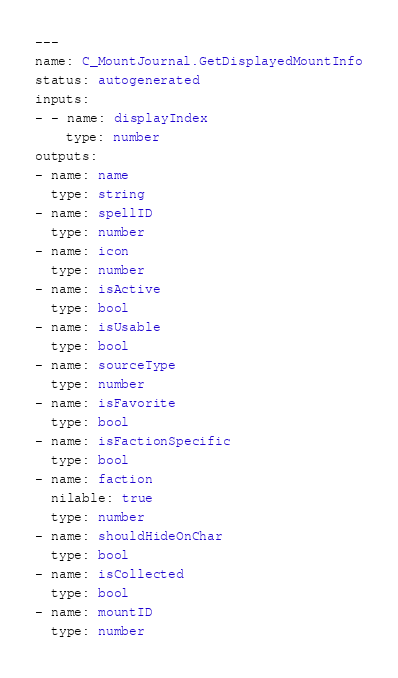<code> <loc_0><loc_0><loc_500><loc_500><_YAML_>---
name: C_MountJournal.GetDisplayedMountInfo
status: autogenerated
inputs:
- - name: displayIndex
    type: number
outputs:
- name: name
  type: string
- name: spellID
  type: number
- name: icon
  type: number
- name: isActive
  type: bool
- name: isUsable
  type: bool
- name: sourceType
  type: number
- name: isFavorite
  type: bool
- name: isFactionSpecific
  type: bool
- name: faction
  nilable: true
  type: number
- name: shouldHideOnChar
  type: bool
- name: isCollected
  type: bool
- name: mountID
  type: number
</code> 